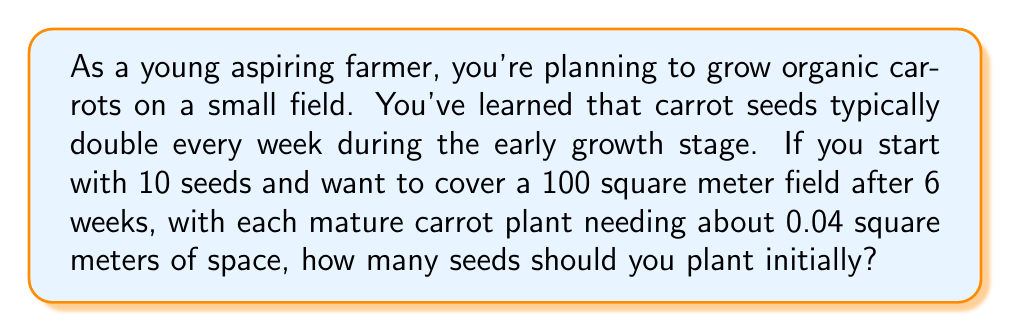Can you solve this math problem? Let's approach this step-by-step:

1) First, we need to calculate how many carrot plants we need for the entire field:
   Field size: 100 square meters
   Space per plant: 0.04 square meters
   Number of plants needed = $\frac{100}{0.04} = 2500$ plants

2) Now, we know that the seeds double every week. This is exponential growth, which can be modeled by the equation:

   $N(t) = N_0 \cdot 2^t$

   Where $N(t)$ is the number of seeds after $t$ weeks, and $N_0$ is the initial number of seeds.

3) After 6 weeks, we want to have 2500 plants. So we can set up the equation:

   $2500 = N_0 \cdot 2^6$

4) Solving for $N_0$:

   $N_0 = \frac{2500}{2^6} = \frac{2500}{64} \approx 39.0625$

5) Since we can't plant a fraction of a seed, we need to round up to the nearest whole number.

Therefore, we need to plant 40 seeds initially to have enough carrots to cover the field after 6 weeks of growth.
Answer: 40 seeds 